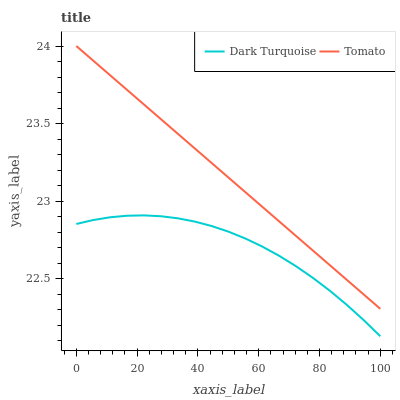Does Dark Turquoise have the minimum area under the curve?
Answer yes or no. Yes. Does Dark Turquoise have the maximum area under the curve?
Answer yes or no. No. Is Dark Turquoise the smoothest?
Answer yes or no. No. Does Dark Turquoise have the highest value?
Answer yes or no. No. Is Dark Turquoise less than Tomato?
Answer yes or no. Yes. Is Tomato greater than Dark Turquoise?
Answer yes or no. Yes. Does Dark Turquoise intersect Tomato?
Answer yes or no. No. 